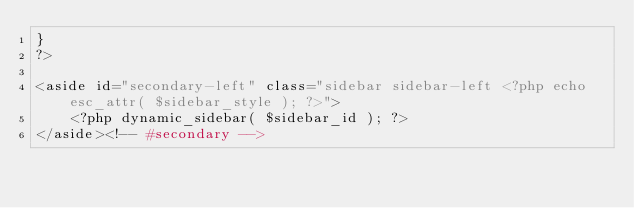Convert code to text. <code><loc_0><loc_0><loc_500><loc_500><_PHP_>}
?>

<aside id="secondary-left" class="sidebar sidebar-left <?php echo esc_attr( $sidebar_style ); ?>">
    <?php dynamic_sidebar( $sidebar_id ); ?>
</aside><!-- #secondary --></code> 